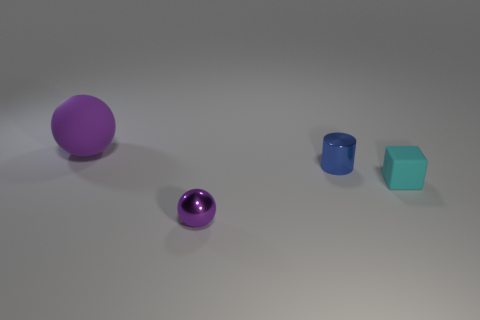Add 3 shiny balls. How many objects exist? 7 Subtract 1 cylinders. How many cylinders are left? 0 Subtract all blocks. How many objects are left? 3 Subtract all tiny things. Subtract all small cyan matte balls. How many objects are left? 1 Add 1 blue metal things. How many blue metal things are left? 2 Add 3 small cylinders. How many small cylinders exist? 4 Subtract 0 brown cylinders. How many objects are left? 4 Subtract all yellow spheres. Subtract all yellow cubes. How many spheres are left? 2 